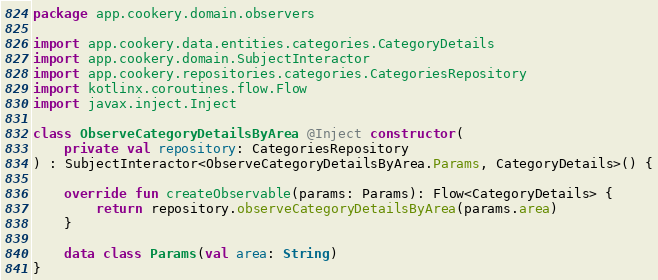<code> <loc_0><loc_0><loc_500><loc_500><_Kotlin_>package app.cookery.domain.observers

import app.cookery.data.entities.categories.CategoryDetails
import app.cookery.domain.SubjectInteractor
import app.cookery.repositories.categories.CategoriesRepository
import kotlinx.coroutines.flow.Flow
import javax.inject.Inject

class ObserveCategoryDetailsByArea @Inject constructor(
    private val repository: CategoriesRepository
) : SubjectInteractor<ObserveCategoryDetailsByArea.Params, CategoryDetails>() {

    override fun createObservable(params: Params): Flow<CategoryDetails> {
        return repository.observeCategoryDetailsByArea(params.area)
    }

    data class Params(val area: String)
}
</code> 